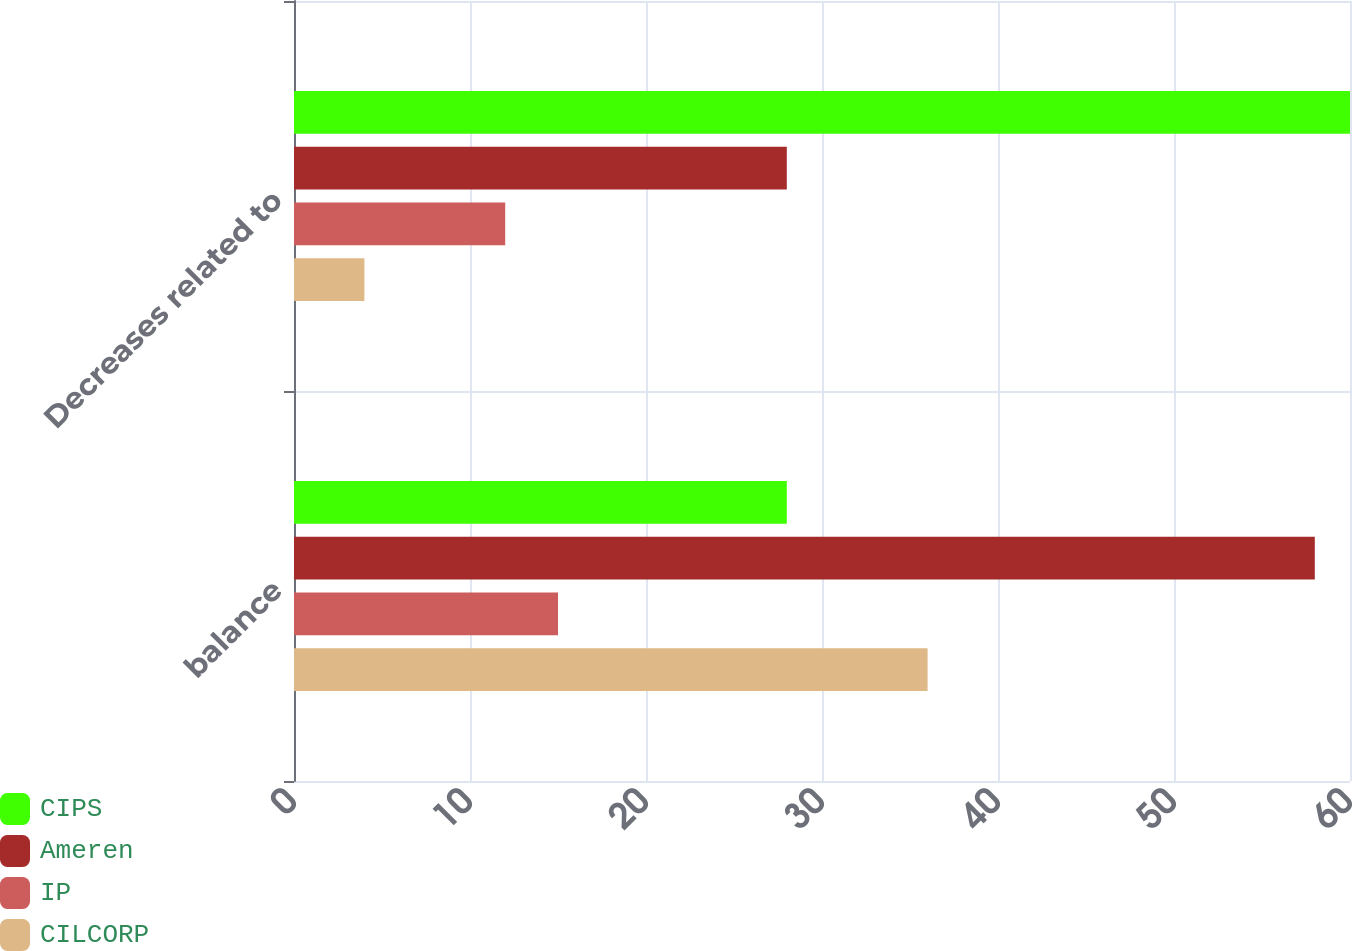Convert chart. <chart><loc_0><loc_0><loc_500><loc_500><stacked_bar_chart><ecel><fcel>balance<fcel>Decreases related to<nl><fcel>CIPS<fcel>28<fcel>60<nl><fcel>Ameren<fcel>58<fcel>28<nl><fcel>IP<fcel>15<fcel>12<nl><fcel>CILCORP<fcel>36<fcel>4<nl></chart> 